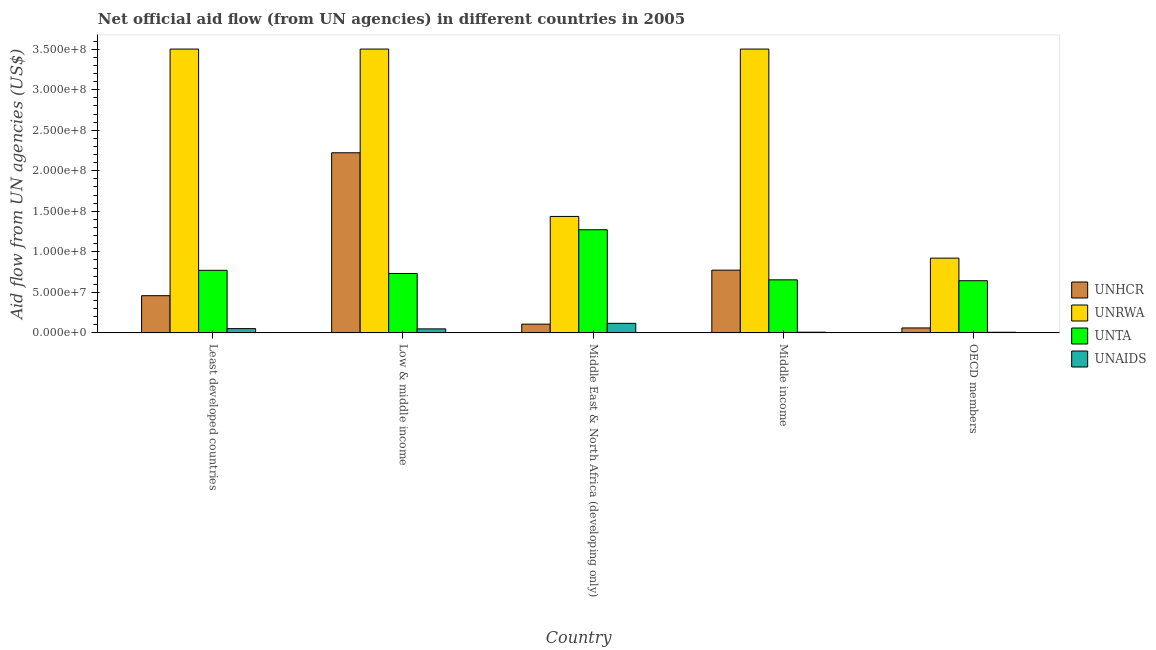How many different coloured bars are there?
Offer a terse response. 4. How many groups of bars are there?
Ensure brevity in your answer.  5. Are the number of bars on each tick of the X-axis equal?
Provide a succinct answer. Yes. How many bars are there on the 5th tick from the right?
Your response must be concise. 4. What is the label of the 4th group of bars from the left?
Your response must be concise. Middle income. What is the amount of aid given by unhcr in Low & middle income?
Ensure brevity in your answer.  2.22e+08. Across all countries, what is the maximum amount of aid given by unta?
Ensure brevity in your answer.  1.27e+08. Across all countries, what is the minimum amount of aid given by unaids?
Ensure brevity in your answer.  8.40e+05. In which country was the amount of aid given by unaids maximum?
Keep it short and to the point. Middle East & North Africa (developing only). What is the total amount of aid given by unaids in the graph?
Your response must be concise. 2.39e+07. What is the difference between the amount of aid given by unrwa in Least developed countries and that in Middle income?
Your answer should be very brief. 0. What is the difference between the amount of aid given by unrwa in Middle East & North Africa (developing only) and the amount of aid given by unhcr in Least developed countries?
Ensure brevity in your answer.  9.77e+07. What is the average amount of aid given by unta per country?
Give a very brief answer. 8.15e+07. What is the difference between the amount of aid given by unta and amount of aid given by unhcr in Middle income?
Keep it short and to the point. -1.20e+07. What is the ratio of the amount of aid given by unaids in Middle income to that in OECD members?
Ensure brevity in your answer.  1.08. Is the difference between the amount of aid given by unrwa in Middle East & North Africa (developing only) and Middle income greater than the difference between the amount of aid given by unaids in Middle East & North Africa (developing only) and Middle income?
Your response must be concise. No. What is the difference between the highest and the second highest amount of aid given by unta?
Offer a very short reply. 5.00e+07. What is the difference between the highest and the lowest amount of aid given by unta?
Your answer should be very brief. 6.28e+07. Is it the case that in every country, the sum of the amount of aid given by unhcr and amount of aid given by unta is greater than the sum of amount of aid given by unrwa and amount of aid given by unaids?
Your answer should be very brief. Yes. What does the 2nd bar from the left in Middle East & North Africa (developing only) represents?
Ensure brevity in your answer.  UNRWA. What does the 1st bar from the right in Middle East & North Africa (developing only) represents?
Provide a short and direct response. UNAIDS. How many bars are there?
Keep it short and to the point. 20. Are all the bars in the graph horizontal?
Offer a very short reply. No. Are the values on the major ticks of Y-axis written in scientific E-notation?
Offer a terse response. Yes. Does the graph contain any zero values?
Offer a terse response. No. Does the graph contain grids?
Provide a short and direct response. No. How are the legend labels stacked?
Your response must be concise. Vertical. What is the title of the graph?
Give a very brief answer. Net official aid flow (from UN agencies) in different countries in 2005. What is the label or title of the Y-axis?
Keep it short and to the point. Aid flow from UN agencies (US$). What is the Aid flow from UN agencies (US$) in UNHCR in Least developed countries?
Ensure brevity in your answer.  4.59e+07. What is the Aid flow from UN agencies (US$) of UNRWA in Least developed countries?
Make the answer very short. 3.50e+08. What is the Aid flow from UN agencies (US$) of UNTA in Least developed countries?
Your answer should be compact. 7.72e+07. What is the Aid flow from UN agencies (US$) of UNAIDS in Least developed countries?
Provide a short and direct response. 5.32e+06. What is the Aid flow from UN agencies (US$) in UNHCR in Low & middle income?
Keep it short and to the point. 2.22e+08. What is the Aid flow from UN agencies (US$) of UNRWA in Low & middle income?
Your answer should be compact. 3.50e+08. What is the Aid flow from UN agencies (US$) of UNTA in Low & middle income?
Your response must be concise. 7.33e+07. What is the Aid flow from UN agencies (US$) in UNAIDS in Low & middle income?
Provide a succinct answer. 5.01e+06. What is the Aid flow from UN agencies (US$) in UNHCR in Middle East & North Africa (developing only)?
Provide a short and direct response. 1.09e+07. What is the Aid flow from UN agencies (US$) of UNRWA in Middle East & North Africa (developing only)?
Provide a succinct answer. 1.44e+08. What is the Aid flow from UN agencies (US$) in UNTA in Middle East & North Africa (developing only)?
Provide a succinct answer. 1.27e+08. What is the Aid flow from UN agencies (US$) in UNAIDS in Middle East & North Africa (developing only)?
Your answer should be very brief. 1.18e+07. What is the Aid flow from UN agencies (US$) of UNHCR in Middle income?
Make the answer very short. 7.74e+07. What is the Aid flow from UN agencies (US$) of UNRWA in Middle income?
Give a very brief answer. 3.50e+08. What is the Aid flow from UN agencies (US$) in UNTA in Middle income?
Make the answer very short. 6.55e+07. What is the Aid flow from UN agencies (US$) in UNAIDS in Middle income?
Your answer should be compact. 9.10e+05. What is the Aid flow from UN agencies (US$) in UNHCR in OECD members?
Your answer should be compact. 6.16e+06. What is the Aid flow from UN agencies (US$) of UNRWA in OECD members?
Make the answer very short. 9.22e+07. What is the Aid flow from UN agencies (US$) in UNTA in OECD members?
Provide a succinct answer. 6.44e+07. What is the Aid flow from UN agencies (US$) in UNAIDS in OECD members?
Provide a short and direct response. 8.40e+05. Across all countries, what is the maximum Aid flow from UN agencies (US$) of UNHCR?
Keep it short and to the point. 2.22e+08. Across all countries, what is the maximum Aid flow from UN agencies (US$) in UNRWA?
Keep it short and to the point. 3.50e+08. Across all countries, what is the maximum Aid flow from UN agencies (US$) of UNTA?
Your response must be concise. 1.27e+08. Across all countries, what is the maximum Aid flow from UN agencies (US$) of UNAIDS?
Make the answer very short. 1.18e+07. Across all countries, what is the minimum Aid flow from UN agencies (US$) in UNHCR?
Ensure brevity in your answer.  6.16e+06. Across all countries, what is the minimum Aid flow from UN agencies (US$) of UNRWA?
Give a very brief answer. 9.22e+07. Across all countries, what is the minimum Aid flow from UN agencies (US$) of UNTA?
Keep it short and to the point. 6.44e+07. Across all countries, what is the minimum Aid flow from UN agencies (US$) in UNAIDS?
Provide a short and direct response. 8.40e+05. What is the total Aid flow from UN agencies (US$) of UNHCR in the graph?
Ensure brevity in your answer.  3.63e+08. What is the total Aid flow from UN agencies (US$) in UNRWA in the graph?
Offer a terse response. 1.29e+09. What is the total Aid flow from UN agencies (US$) of UNTA in the graph?
Give a very brief answer. 4.08e+08. What is the total Aid flow from UN agencies (US$) of UNAIDS in the graph?
Give a very brief answer. 2.39e+07. What is the difference between the Aid flow from UN agencies (US$) in UNHCR in Least developed countries and that in Low & middle income?
Provide a succinct answer. -1.76e+08. What is the difference between the Aid flow from UN agencies (US$) in UNRWA in Least developed countries and that in Low & middle income?
Make the answer very short. 0. What is the difference between the Aid flow from UN agencies (US$) in UNTA in Least developed countries and that in Low & middle income?
Your answer should be very brief. 3.89e+06. What is the difference between the Aid flow from UN agencies (US$) of UNAIDS in Least developed countries and that in Low & middle income?
Offer a very short reply. 3.10e+05. What is the difference between the Aid flow from UN agencies (US$) in UNHCR in Least developed countries and that in Middle East & North Africa (developing only)?
Make the answer very short. 3.51e+07. What is the difference between the Aid flow from UN agencies (US$) of UNRWA in Least developed countries and that in Middle East & North Africa (developing only)?
Provide a short and direct response. 2.06e+08. What is the difference between the Aid flow from UN agencies (US$) in UNTA in Least developed countries and that in Middle East & North Africa (developing only)?
Make the answer very short. -5.00e+07. What is the difference between the Aid flow from UN agencies (US$) of UNAIDS in Least developed countries and that in Middle East & North Africa (developing only)?
Offer a very short reply. -6.52e+06. What is the difference between the Aid flow from UN agencies (US$) in UNHCR in Least developed countries and that in Middle income?
Provide a succinct answer. -3.15e+07. What is the difference between the Aid flow from UN agencies (US$) in UNTA in Least developed countries and that in Middle income?
Provide a succinct answer. 1.17e+07. What is the difference between the Aid flow from UN agencies (US$) of UNAIDS in Least developed countries and that in Middle income?
Ensure brevity in your answer.  4.41e+06. What is the difference between the Aid flow from UN agencies (US$) in UNHCR in Least developed countries and that in OECD members?
Provide a short and direct response. 3.98e+07. What is the difference between the Aid flow from UN agencies (US$) of UNRWA in Least developed countries and that in OECD members?
Provide a short and direct response. 2.58e+08. What is the difference between the Aid flow from UN agencies (US$) in UNTA in Least developed countries and that in OECD members?
Ensure brevity in your answer.  1.28e+07. What is the difference between the Aid flow from UN agencies (US$) of UNAIDS in Least developed countries and that in OECD members?
Give a very brief answer. 4.48e+06. What is the difference between the Aid flow from UN agencies (US$) in UNHCR in Low & middle income and that in Middle East & North Africa (developing only)?
Give a very brief answer. 2.11e+08. What is the difference between the Aid flow from UN agencies (US$) in UNRWA in Low & middle income and that in Middle East & North Africa (developing only)?
Your response must be concise. 2.06e+08. What is the difference between the Aid flow from UN agencies (US$) of UNTA in Low & middle income and that in Middle East & North Africa (developing only)?
Keep it short and to the point. -5.39e+07. What is the difference between the Aid flow from UN agencies (US$) of UNAIDS in Low & middle income and that in Middle East & North Africa (developing only)?
Offer a very short reply. -6.83e+06. What is the difference between the Aid flow from UN agencies (US$) in UNHCR in Low & middle income and that in Middle income?
Provide a succinct answer. 1.45e+08. What is the difference between the Aid flow from UN agencies (US$) of UNRWA in Low & middle income and that in Middle income?
Your response must be concise. 0. What is the difference between the Aid flow from UN agencies (US$) in UNTA in Low & middle income and that in Middle income?
Ensure brevity in your answer.  7.85e+06. What is the difference between the Aid flow from UN agencies (US$) of UNAIDS in Low & middle income and that in Middle income?
Provide a short and direct response. 4.10e+06. What is the difference between the Aid flow from UN agencies (US$) in UNHCR in Low & middle income and that in OECD members?
Keep it short and to the point. 2.16e+08. What is the difference between the Aid flow from UN agencies (US$) in UNRWA in Low & middle income and that in OECD members?
Provide a short and direct response. 2.58e+08. What is the difference between the Aid flow from UN agencies (US$) in UNTA in Low & middle income and that in OECD members?
Give a very brief answer. 8.93e+06. What is the difference between the Aid flow from UN agencies (US$) in UNAIDS in Low & middle income and that in OECD members?
Offer a terse response. 4.17e+06. What is the difference between the Aid flow from UN agencies (US$) of UNHCR in Middle East & North Africa (developing only) and that in Middle income?
Your answer should be very brief. -6.66e+07. What is the difference between the Aid flow from UN agencies (US$) in UNRWA in Middle East & North Africa (developing only) and that in Middle income?
Your answer should be very brief. -2.06e+08. What is the difference between the Aid flow from UN agencies (US$) of UNTA in Middle East & North Africa (developing only) and that in Middle income?
Provide a short and direct response. 6.18e+07. What is the difference between the Aid flow from UN agencies (US$) of UNAIDS in Middle East & North Africa (developing only) and that in Middle income?
Keep it short and to the point. 1.09e+07. What is the difference between the Aid flow from UN agencies (US$) in UNHCR in Middle East & North Africa (developing only) and that in OECD members?
Keep it short and to the point. 4.71e+06. What is the difference between the Aid flow from UN agencies (US$) in UNRWA in Middle East & North Africa (developing only) and that in OECD members?
Ensure brevity in your answer.  5.14e+07. What is the difference between the Aid flow from UN agencies (US$) in UNTA in Middle East & North Africa (developing only) and that in OECD members?
Make the answer very short. 6.28e+07. What is the difference between the Aid flow from UN agencies (US$) of UNAIDS in Middle East & North Africa (developing only) and that in OECD members?
Offer a very short reply. 1.10e+07. What is the difference between the Aid flow from UN agencies (US$) of UNHCR in Middle income and that in OECD members?
Your response must be concise. 7.13e+07. What is the difference between the Aid flow from UN agencies (US$) in UNRWA in Middle income and that in OECD members?
Keep it short and to the point. 2.58e+08. What is the difference between the Aid flow from UN agencies (US$) of UNTA in Middle income and that in OECD members?
Keep it short and to the point. 1.08e+06. What is the difference between the Aid flow from UN agencies (US$) in UNHCR in Least developed countries and the Aid flow from UN agencies (US$) in UNRWA in Low & middle income?
Provide a short and direct response. -3.04e+08. What is the difference between the Aid flow from UN agencies (US$) of UNHCR in Least developed countries and the Aid flow from UN agencies (US$) of UNTA in Low & middle income?
Give a very brief answer. -2.74e+07. What is the difference between the Aid flow from UN agencies (US$) in UNHCR in Least developed countries and the Aid flow from UN agencies (US$) in UNAIDS in Low & middle income?
Offer a very short reply. 4.09e+07. What is the difference between the Aid flow from UN agencies (US$) of UNRWA in Least developed countries and the Aid flow from UN agencies (US$) of UNTA in Low & middle income?
Give a very brief answer. 2.77e+08. What is the difference between the Aid flow from UN agencies (US$) of UNRWA in Least developed countries and the Aid flow from UN agencies (US$) of UNAIDS in Low & middle income?
Provide a succinct answer. 3.45e+08. What is the difference between the Aid flow from UN agencies (US$) in UNTA in Least developed countries and the Aid flow from UN agencies (US$) in UNAIDS in Low & middle income?
Your answer should be very brief. 7.22e+07. What is the difference between the Aid flow from UN agencies (US$) of UNHCR in Least developed countries and the Aid flow from UN agencies (US$) of UNRWA in Middle East & North Africa (developing only)?
Ensure brevity in your answer.  -9.77e+07. What is the difference between the Aid flow from UN agencies (US$) in UNHCR in Least developed countries and the Aid flow from UN agencies (US$) in UNTA in Middle East & North Africa (developing only)?
Offer a terse response. -8.13e+07. What is the difference between the Aid flow from UN agencies (US$) of UNHCR in Least developed countries and the Aid flow from UN agencies (US$) of UNAIDS in Middle East & North Africa (developing only)?
Offer a terse response. 3.41e+07. What is the difference between the Aid flow from UN agencies (US$) in UNRWA in Least developed countries and the Aid flow from UN agencies (US$) in UNTA in Middle East & North Africa (developing only)?
Offer a very short reply. 2.23e+08. What is the difference between the Aid flow from UN agencies (US$) of UNRWA in Least developed countries and the Aid flow from UN agencies (US$) of UNAIDS in Middle East & North Africa (developing only)?
Make the answer very short. 3.38e+08. What is the difference between the Aid flow from UN agencies (US$) of UNTA in Least developed countries and the Aid flow from UN agencies (US$) of UNAIDS in Middle East & North Africa (developing only)?
Make the answer very short. 6.54e+07. What is the difference between the Aid flow from UN agencies (US$) of UNHCR in Least developed countries and the Aid flow from UN agencies (US$) of UNRWA in Middle income?
Keep it short and to the point. -3.04e+08. What is the difference between the Aid flow from UN agencies (US$) in UNHCR in Least developed countries and the Aid flow from UN agencies (US$) in UNTA in Middle income?
Your response must be concise. -1.96e+07. What is the difference between the Aid flow from UN agencies (US$) in UNHCR in Least developed countries and the Aid flow from UN agencies (US$) in UNAIDS in Middle income?
Give a very brief answer. 4.50e+07. What is the difference between the Aid flow from UN agencies (US$) of UNRWA in Least developed countries and the Aid flow from UN agencies (US$) of UNTA in Middle income?
Give a very brief answer. 2.85e+08. What is the difference between the Aid flow from UN agencies (US$) of UNRWA in Least developed countries and the Aid flow from UN agencies (US$) of UNAIDS in Middle income?
Offer a very short reply. 3.49e+08. What is the difference between the Aid flow from UN agencies (US$) of UNTA in Least developed countries and the Aid flow from UN agencies (US$) of UNAIDS in Middle income?
Your answer should be very brief. 7.63e+07. What is the difference between the Aid flow from UN agencies (US$) of UNHCR in Least developed countries and the Aid flow from UN agencies (US$) of UNRWA in OECD members?
Ensure brevity in your answer.  -4.63e+07. What is the difference between the Aid flow from UN agencies (US$) of UNHCR in Least developed countries and the Aid flow from UN agencies (US$) of UNTA in OECD members?
Provide a succinct answer. -1.85e+07. What is the difference between the Aid flow from UN agencies (US$) in UNHCR in Least developed countries and the Aid flow from UN agencies (US$) in UNAIDS in OECD members?
Your answer should be compact. 4.51e+07. What is the difference between the Aid flow from UN agencies (US$) of UNRWA in Least developed countries and the Aid flow from UN agencies (US$) of UNTA in OECD members?
Make the answer very short. 2.86e+08. What is the difference between the Aid flow from UN agencies (US$) in UNRWA in Least developed countries and the Aid flow from UN agencies (US$) in UNAIDS in OECD members?
Provide a short and direct response. 3.49e+08. What is the difference between the Aid flow from UN agencies (US$) of UNTA in Least developed countries and the Aid flow from UN agencies (US$) of UNAIDS in OECD members?
Make the answer very short. 7.64e+07. What is the difference between the Aid flow from UN agencies (US$) of UNHCR in Low & middle income and the Aid flow from UN agencies (US$) of UNRWA in Middle East & North Africa (developing only)?
Your response must be concise. 7.85e+07. What is the difference between the Aid flow from UN agencies (US$) of UNHCR in Low & middle income and the Aid flow from UN agencies (US$) of UNTA in Middle East & North Africa (developing only)?
Your answer should be very brief. 9.49e+07. What is the difference between the Aid flow from UN agencies (US$) in UNHCR in Low & middle income and the Aid flow from UN agencies (US$) in UNAIDS in Middle East & North Africa (developing only)?
Make the answer very short. 2.10e+08. What is the difference between the Aid flow from UN agencies (US$) of UNRWA in Low & middle income and the Aid flow from UN agencies (US$) of UNTA in Middle East & North Africa (developing only)?
Offer a very short reply. 2.23e+08. What is the difference between the Aid flow from UN agencies (US$) of UNRWA in Low & middle income and the Aid flow from UN agencies (US$) of UNAIDS in Middle East & North Africa (developing only)?
Provide a short and direct response. 3.38e+08. What is the difference between the Aid flow from UN agencies (US$) in UNTA in Low & middle income and the Aid flow from UN agencies (US$) in UNAIDS in Middle East & North Africa (developing only)?
Make the answer very short. 6.15e+07. What is the difference between the Aid flow from UN agencies (US$) in UNHCR in Low & middle income and the Aid flow from UN agencies (US$) in UNRWA in Middle income?
Offer a very short reply. -1.28e+08. What is the difference between the Aid flow from UN agencies (US$) of UNHCR in Low & middle income and the Aid flow from UN agencies (US$) of UNTA in Middle income?
Your response must be concise. 1.57e+08. What is the difference between the Aid flow from UN agencies (US$) in UNHCR in Low & middle income and the Aid flow from UN agencies (US$) in UNAIDS in Middle income?
Offer a terse response. 2.21e+08. What is the difference between the Aid flow from UN agencies (US$) of UNRWA in Low & middle income and the Aid flow from UN agencies (US$) of UNTA in Middle income?
Make the answer very short. 2.85e+08. What is the difference between the Aid flow from UN agencies (US$) of UNRWA in Low & middle income and the Aid flow from UN agencies (US$) of UNAIDS in Middle income?
Make the answer very short. 3.49e+08. What is the difference between the Aid flow from UN agencies (US$) in UNTA in Low & middle income and the Aid flow from UN agencies (US$) in UNAIDS in Middle income?
Provide a short and direct response. 7.24e+07. What is the difference between the Aid flow from UN agencies (US$) of UNHCR in Low & middle income and the Aid flow from UN agencies (US$) of UNRWA in OECD members?
Make the answer very short. 1.30e+08. What is the difference between the Aid flow from UN agencies (US$) in UNHCR in Low & middle income and the Aid flow from UN agencies (US$) in UNTA in OECD members?
Your answer should be compact. 1.58e+08. What is the difference between the Aid flow from UN agencies (US$) in UNHCR in Low & middle income and the Aid flow from UN agencies (US$) in UNAIDS in OECD members?
Provide a succinct answer. 2.21e+08. What is the difference between the Aid flow from UN agencies (US$) of UNRWA in Low & middle income and the Aid flow from UN agencies (US$) of UNTA in OECD members?
Offer a terse response. 2.86e+08. What is the difference between the Aid flow from UN agencies (US$) in UNRWA in Low & middle income and the Aid flow from UN agencies (US$) in UNAIDS in OECD members?
Provide a succinct answer. 3.49e+08. What is the difference between the Aid flow from UN agencies (US$) of UNTA in Low & middle income and the Aid flow from UN agencies (US$) of UNAIDS in OECD members?
Your answer should be compact. 7.25e+07. What is the difference between the Aid flow from UN agencies (US$) of UNHCR in Middle East & North Africa (developing only) and the Aid flow from UN agencies (US$) of UNRWA in Middle income?
Offer a very short reply. -3.39e+08. What is the difference between the Aid flow from UN agencies (US$) in UNHCR in Middle East & North Africa (developing only) and the Aid flow from UN agencies (US$) in UNTA in Middle income?
Keep it short and to the point. -5.46e+07. What is the difference between the Aid flow from UN agencies (US$) of UNHCR in Middle East & North Africa (developing only) and the Aid flow from UN agencies (US$) of UNAIDS in Middle income?
Your answer should be very brief. 9.96e+06. What is the difference between the Aid flow from UN agencies (US$) of UNRWA in Middle East & North Africa (developing only) and the Aid flow from UN agencies (US$) of UNTA in Middle income?
Provide a short and direct response. 7.82e+07. What is the difference between the Aid flow from UN agencies (US$) of UNRWA in Middle East & North Africa (developing only) and the Aid flow from UN agencies (US$) of UNAIDS in Middle income?
Give a very brief answer. 1.43e+08. What is the difference between the Aid flow from UN agencies (US$) of UNTA in Middle East & North Africa (developing only) and the Aid flow from UN agencies (US$) of UNAIDS in Middle income?
Offer a very short reply. 1.26e+08. What is the difference between the Aid flow from UN agencies (US$) of UNHCR in Middle East & North Africa (developing only) and the Aid flow from UN agencies (US$) of UNRWA in OECD members?
Offer a terse response. -8.14e+07. What is the difference between the Aid flow from UN agencies (US$) in UNHCR in Middle East & North Africa (developing only) and the Aid flow from UN agencies (US$) in UNTA in OECD members?
Provide a succinct answer. -5.35e+07. What is the difference between the Aid flow from UN agencies (US$) in UNHCR in Middle East & North Africa (developing only) and the Aid flow from UN agencies (US$) in UNAIDS in OECD members?
Provide a short and direct response. 1.00e+07. What is the difference between the Aid flow from UN agencies (US$) in UNRWA in Middle East & North Africa (developing only) and the Aid flow from UN agencies (US$) in UNTA in OECD members?
Give a very brief answer. 7.93e+07. What is the difference between the Aid flow from UN agencies (US$) in UNRWA in Middle East & North Africa (developing only) and the Aid flow from UN agencies (US$) in UNAIDS in OECD members?
Give a very brief answer. 1.43e+08. What is the difference between the Aid flow from UN agencies (US$) in UNTA in Middle East & North Africa (developing only) and the Aid flow from UN agencies (US$) in UNAIDS in OECD members?
Your answer should be very brief. 1.26e+08. What is the difference between the Aid flow from UN agencies (US$) in UNHCR in Middle income and the Aid flow from UN agencies (US$) in UNRWA in OECD members?
Offer a very short reply. -1.48e+07. What is the difference between the Aid flow from UN agencies (US$) of UNHCR in Middle income and the Aid flow from UN agencies (US$) of UNTA in OECD members?
Keep it short and to the point. 1.30e+07. What is the difference between the Aid flow from UN agencies (US$) in UNHCR in Middle income and the Aid flow from UN agencies (US$) in UNAIDS in OECD members?
Your answer should be compact. 7.66e+07. What is the difference between the Aid flow from UN agencies (US$) in UNRWA in Middle income and the Aid flow from UN agencies (US$) in UNTA in OECD members?
Ensure brevity in your answer.  2.86e+08. What is the difference between the Aid flow from UN agencies (US$) of UNRWA in Middle income and the Aid flow from UN agencies (US$) of UNAIDS in OECD members?
Provide a succinct answer. 3.49e+08. What is the difference between the Aid flow from UN agencies (US$) in UNTA in Middle income and the Aid flow from UN agencies (US$) in UNAIDS in OECD members?
Make the answer very short. 6.46e+07. What is the average Aid flow from UN agencies (US$) in UNHCR per country?
Provide a succinct answer. 7.25e+07. What is the average Aid flow from UN agencies (US$) of UNRWA per country?
Offer a terse response. 2.57e+08. What is the average Aid flow from UN agencies (US$) of UNTA per country?
Offer a very short reply. 8.15e+07. What is the average Aid flow from UN agencies (US$) of UNAIDS per country?
Provide a succinct answer. 4.78e+06. What is the difference between the Aid flow from UN agencies (US$) in UNHCR and Aid flow from UN agencies (US$) in UNRWA in Least developed countries?
Make the answer very short. -3.04e+08. What is the difference between the Aid flow from UN agencies (US$) of UNHCR and Aid flow from UN agencies (US$) of UNTA in Least developed countries?
Offer a terse response. -3.13e+07. What is the difference between the Aid flow from UN agencies (US$) of UNHCR and Aid flow from UN agencies (US$) of UNAIDS in Least developed countries?
Give a very brief answer. 4.06e+07. What is the difference between the Aid flow from UN agencies (US$) of UNRWA and Aid flow from UN agencies (US$) of UNTA in Least developed countries?
Your response must be concise. 2.73e+08. What is the difference between the Aid flow from UN agencies (US$) of UNRWA and Aid flow from UN agencies (US$) of UNAIDS in Least developed countries?
Provide a short and direct response. 3.45e+08. What is the difference between the Aid flow from UN agencies (US$) of UNTA and Aid flow from UN agencies (US$) of UNAIDS in Least developed countries?
Your answer should be compact. 7.19e+07. What is the difference between the Aid flow from UN agencies (US$) in UNHCR and Aid flow from UN agencies (US$) in UNRWA in Low & middle income?
Your answer should be very brief. -1.28e+08. What is the difference between the Aid flow from UN agencies (US$) of UNHCR and Aid flow from UN agencies (US$) of UNTA in Low & middle income?
Provide a succinct answer. 1.49e+08. What is the difference between the Aid flow from UN agencies (US$) in UNHCR and Aid flow from UN agencies (US$) in UNAIDS in Low & middle income?
Your response must be concise. 2.17e+08. What is the difference between the Aid flow from UN agencies (US$) of UNRWA and Aid flow from UN agencies (US$) of UNTA in Low & middle income?
Provide a succinct answer. 2.77e+08. What is the difference between the Aid flow from UN agencies (US$) in UNRWA and Aid flow from UN agencies (US$) in UNAIDS in Low & middle income?
Provide a succinct answer. 3.45e+08. What is the difference between the Aid flow from UN agencies (US$) of UNTA and Aid flow from UN agencies (US$) of UNAIDS in Low & middle income?
Your answer should be very brief. 6.83e+07. What is the difference between the Aid flow from UN agencies (US$) of UNHCR and Aid flow from UN agencies (US$) of UNRWA in Middle East & North Africa (developing only)?
Your answer should be very brief. -1.33e+08. What is the difference between the Aid flow from UN agencies (US$) of UNHCR and Aid flow from UN agencies (US$) of UNTA in Middle East & North Africa (developing only)?
Offer a very short reply. -1.16e+08. What is the difference between the Aid flow from UN agencies (US$) of UNHCR and Aid flow from UN agencies (US$) of UNAIDS in Middle East & North Africa (developing only)?
Make the answer very short. -9.70e+05. What is the difference between the Aid flow from UN agencies (US$) of UNRWA and Aid flow from UN agencies (US$) of UNTA in Middle East & North Africa (developing only)?
Ensure brevity in your answer.  1.64e+07. What is the difference between the Aid flow from UN agencies (US$) in UNRWA and Aid flow from UN agencies (US$) in UNAIDS in Middle East & North Africa (developing only)?
Give a very brief answer. 1.32e+08. What is the difference between the Aid flow from UN agencies (US$) of UNTA and Aid flow from UN agencies (US$) of UNAIDS in Middle East & North Africa (developing only)?
Keep it short and to the point. 1.15e+08. What is the difference between the Aid flow from UN agencies (US$) of UNHCR and Aid flow from UN agencies (US$) of UNRWA in Middle income?
Offer a terse response. -2.73e+08. What is the difference between the Aid flow from UN agencies (US$) in UNHCR and Aid flow from UN agencies (US$) in UNTA in Middle income?
Give a very brief answer. 1.20e+07. What is the difference between the Aid flow from UN agencies (US$) in UNHCR and Aid flow from UN agencies (US$) in UNAIDS in Middle income?
Provide a succinct answer. 7.65e+07. What is the difference between the Aid flow from UN agencies (US$) in UNRWA and Aid flow from UN agencies (US$) in UNTA in Middle income?
Your answer should be compact. 2.85e+08. What is the difference between the Aid flow from UN agencies (US$) in UNRWA and Aid flow from UN agencies (US$) in UNAIDS in Middle income?
Ensure brevity in your answer.  3.49e+08. What is the difference between the Aid flow from UN agencies (US$) of UNTA and Aid flow from UN agencies (US$) of UNAIDS in Middle income?
Your response must be concise. 6.46e+07. What is the difference between the Aid flow from UN agencies (US$) in UNHCR and Aid flow from UN agencies (US$) in UNRWA in OECD members?
Offer a very short reply. -8.61e+07. What is the difference between the Aid flow from UN agencies (US$) of UNHCR and Aid flow from UN agencies (US$) of UNTA in OECD members?
Make the answer very short. -5.82e+07. What is the difference between the Aid flow from UN agencies (US$) in UNHCR and Aid flow from UN agencies (US$) in UNAIDS in OECD members?
Keep it short and to the point. 5.32e+06. What is the difference between the Aid flow from UN agencies (US$) of UNRWA and Aid flow from UN agencies (US$) of UNTA in OECD members?
Keep it short and to the point. 2.78e+07. What is the difference between the Aid flow from UN agencies (US$) in UNRWA and Aid flow from UN agencies (US$) in UNAIDS in OECD members?
Make the answer very short. 9.14e+07. What is the difference between the Aid flow from UN agencies (US$) of UNTA and Aid flow from UN agencies (US$) of UNAIDS in OECD members?
Your response must be concise. 6.36e+07. What is the ratio of the Aid flow from UN agencies (US$) in UNHCR in Least developed countries to that in Low & middle income?
Offer a terse response. 0.21. What is the ratio of the Aid flow from UN agencies (US$) of UNTA in Least developed countries to that in Low & middle income?
Make the answer very short. 1.05. What is the ratio of the Aid flow from UN agencies (US$) in UNAIDS in Least developed countries to that in Low & middle income?
Offer a very short reply. 1.06. What is the ratio of the Aid flow from UN agencies (US$) in UNHCR in Least developed countries to that in Middle East & North Africa (developing only)?
Provide a succinct answer. 4.23. What is the ratio of the Aid flow from UN agencies (US$) of UNRWA in Least developed countries to that in Middle East & North Africa (developing only)?
Offer a very short reply. 2.44. What is the ratio of the Aid flow from UN agencies (US$) of UNTA in Least developed countries to that in Middle East & North Africa (developing only)?
Make the answer very short. 0.61. What is the ratio of the Aid flow from UN agencies (US$) of UNAIDS in Least developed countries to that in Middle East & North Africa (developing only)?
Offer a very short reply. 0.45. What is the ratio of the Aid flow from UN agencies (US$) of UNHCR in Least developed countries to that in Middle income?
Make the answer very short. 0.59. What is the ratio of the Aid flow from UN agencies (US$) of UNRWA in Least developed countries to that in Middle income?
Keep it short and to the point. 1. What is the ratio of the Aid flow from UN agencies (US$) in UNTA in Least developed countries to that in Middle income?
Offer a terse response. 1.18. What is the ratio of the Aid flow from UN agencies (US$) in UNAIDS in Least developed countries to that in Middle income?
Offer a terse response. 5.85. What is the ratio of the Aid flow from UN agencies (US$) of UNHCR in Least developed countries to that in OECD members?
Your answer should be compact. 7.46. What is the ratio of the Aid flow from UN agencies (US$) of UNRWA in Least developed countries to that in OECD members?
Keep it short and to the point. 3.8. What is the ratio of the Aid flow from UN agencies (US$) of UNTA in Least developed countries to that in OECD members?
Your answer should be compact. 1.2. What is the ratio of the Aid flow from UN agencies (US$) in UNAIDS in Least developed countries to that in OECD members?
Make the answer very short. 6.33. What is the ratio of the Aid flow from UN agencies (US$) of UNHCR in Low & middle income to that in Middle East & North Africa (developing only)?
Your answer should be very brief. 20.44. What is the ratio of the Aid flow from UN agencies (US$) in UNRWA in Low & middle income to that in Middle East & North Africa (developing only)?
Your answer should be compact. 2.44. What is the ratio of the Aid flow from UN agencies (US$) in UNTA in Low & middle income to that in Middle East & North Africa (developing only)?
Keep it short and to the point. 0.58. What is the ratio of the Aid flow from UN agencies (US$) in UNAIDS in Low & middle income to that in Middle East & North Africa (developing only)?
Provide a short and direct response. 0.42. What is the ratio of the Aid flow from UN agencies (US$) in UNHCR in Low & middle income to that in Middle income?
Offer a terse response. 2.87. What is the ratio of the Aid flow from UN agencies (US$) of UNRWA in Low & middle income to that in Middle income?
Your answer should be compact. 1. What is the ratio of the Aid flow from UN agencies (US$) in UNTA in Low & middle income to that in Middle income?
Keep it short and to the point. 1.12. What is the ratio of the Aid flow from UN agencies (US$) in UNAIDS in Low & middle income to that in Middle income?
Your response must be concise. 5.51. What is the ratio of the Aid flow from UN agencies (US$) in UNHCR in Low & middle income to that in OECD members?
Make the answer very short. 36.07. What is the ratio of the Aid flow from UN agencies (US$) of UNRWA in Low & middle income to that in OECD members?
Your response must be concise. 3.8. What is the ratio of the Aid flow from UN agencies (US$) in UNTA in Low & middle income to that in OECD members?
Provide a short and direct response. 1.14. What is the ratio of the Aid flow from UN agencies (US$) in UNAIDS in Low & middle income to that in OECD members?
Your answer should be compact. 5.96. What is the ratio of the Aid flow from UN agencies (US$) of UNHCR in Middle East & North Africa (developing only) to that in Middle income?
Offer a terse response. 0.14. What is the ratio of the Aid flow from UN agencies (US$) in UNRWA in Middle East & North Africa (developing only) to that in Middle income?
Your response must be concise. 0.41. What is the ratio of the Aid flow from UN agencies (US$) of UNTA in Middle East & North Africa (developing only) to that in Middle income?
Make the answer very short. 1.94. What is the ratio of the Aid flow from UN agencies (US$) of UNAIDS in Middle East & North Africa (developing only) to that in Middle income?
Your answer should be very brief. 13.01. What is the ratio of the Aid flow from UN agencies (US$) in UNHCR in Middle East & North Africa (developing only) to that in OECD members?
Ensure brevity in your answer.  1.76. What is the ratio of the Aid flow from UN agencies (US$) of UNRWA in Middle East & North Africa (developing only) to that in OECD members?
Make the answer very short. 1.56. What is the ratio of the Aid flow from UN agencies (US$) in UNTA in Middle East & North Africa (developing only) to that in OECD members?
Your answer should be compact. 1.98. What is the ratio of the Aid flow from UN agencies (US$) in UNAIDS in Middle East & North Africa (developing only) to that in OECD members?
Give a very brief answer. 14.1. What is the ratio of the Aid flow from UN agencies (US$) in UNHCR in Middle income to that in OECD members?
Keep it short and to the point. 12.57. What is the ratio of the Aid flow from UN agencies (US$) in UNRWA in Middle income to that in OECD members?
Offer a very short reply. 3.8. What is the ratio of the Aid flow from UN agencies (US$) in UNTA in Middle income to that in OECD members?
Provide a succinct answer. 1.02. What is the ratio of the Aid flow from UN agencies (US$) of UNAIDS in Middle income to that in OECD members?
Make the answer very short. 1.08. What is the difference between the highest and the second highest Aid flow from UN agencies (US$) of UNHCR?
Keep it short and to the point. 1.45e+08. What is the difference between the highest and the second highest Aid flow from UN agencies (US$) in UNRWA?
Give a very brief answer. 0. What is the difference between the highest and the second highest Aid flow from UN agencies (US$) in UNTA?
Offer a terse response. 5.00e+07. What is the difference between the highest and the second highest Aid flow from UN agencies (US$) in UNAIDS?
Your response must be concise. 6.52e+06. What is the difference between the highest and the lowest Aid flow from UN agencies (US$) of UNHCR?
Provide a succinct answer. 2.16e+08. What is the difference between the highest and the lowest Aid flow from UN agencies (US$) in UNRWA?
Provide a short and direct response. 2.58e+08. What is the difference between the highest and the lowest Aid flow from UN agencies (US$) in UNTA?
Your answer should be compact. 6.28e+07. What is the difference between the highest and the lowest Aid flow from UN agencies (US$) in UNAIDS?
Make the answer very short. 1.10e+07. 